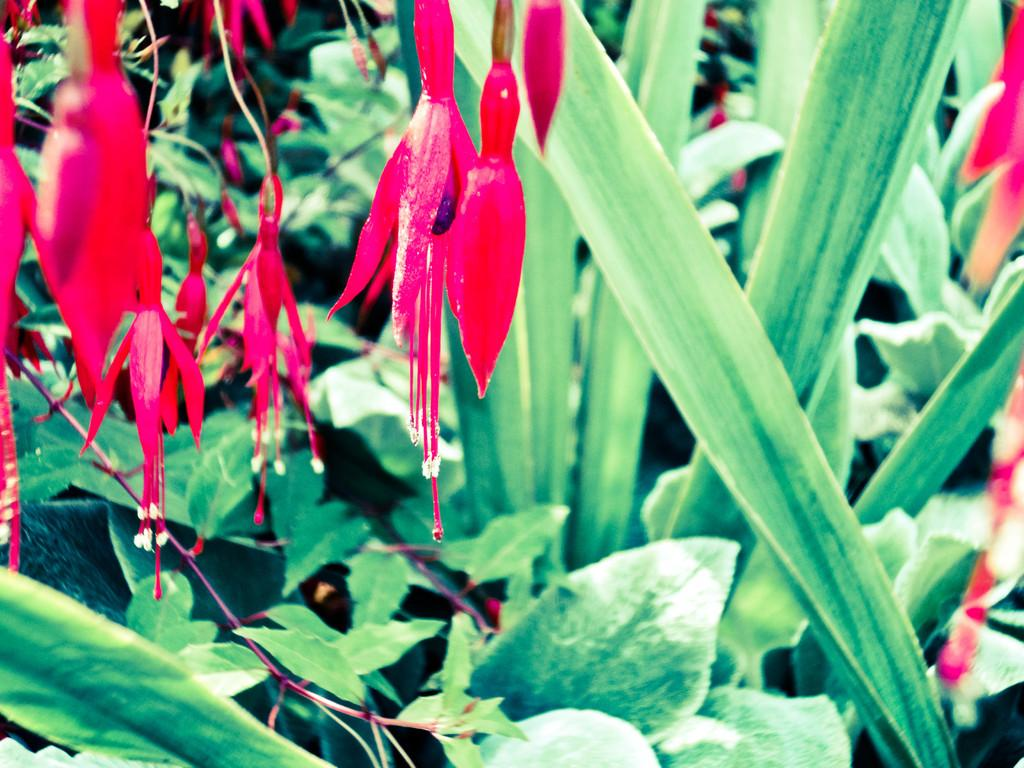What type of vegetation is present in the image? There are green-colored leaves in the image. What color are the flowers in the image? There are red-colored flowers in the image. What group of people is sailing in the image? There are no people or sailing activity present in the image. How does the disgust factor contribute to the image? The image does not convey any sense of disgust, as it features green leaves and red flowers. 